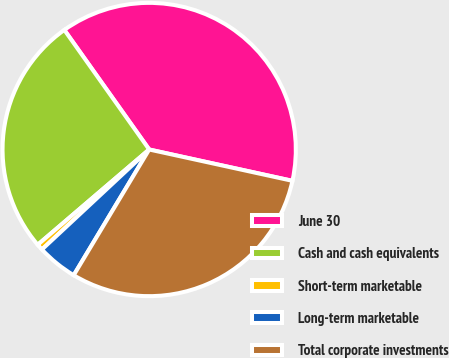Convert chart. <chart><loc_0><loc_0><loc_500><loc_500><pie_chart><fcel>June 30<fcel>Cash and cash equivalents<fcel>Short-term marketable<fcel>Long-term marketable<fcel>Total corporate investments<nl><fcel>38.25%<fcel>26.43%<fcel>0.69%<fcel>4.45%<fcel>30.18%<nl></chart> 